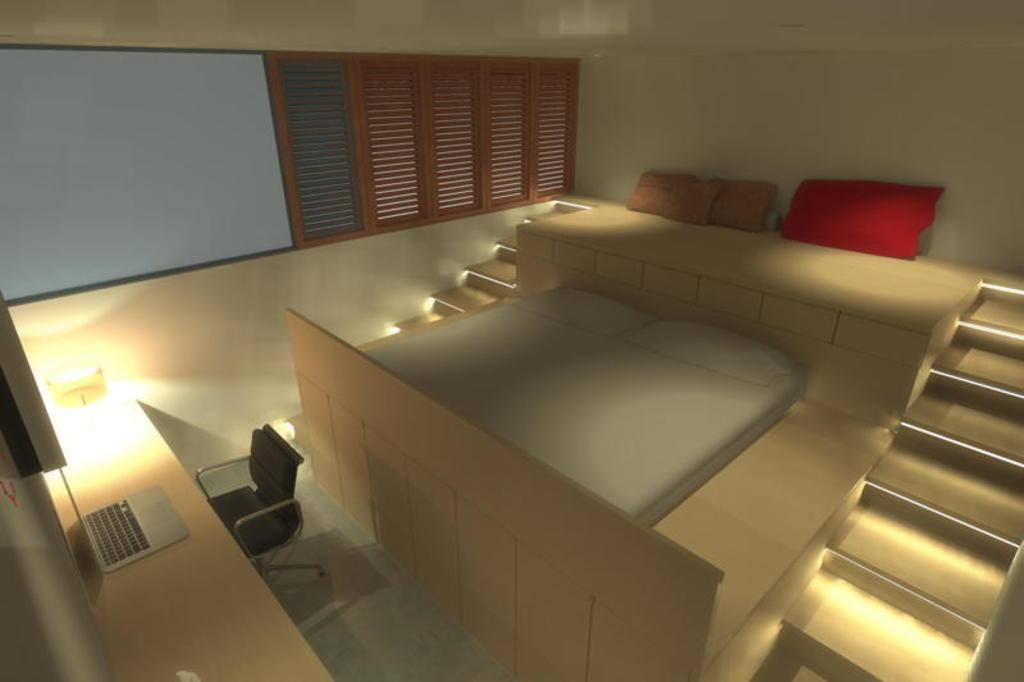What type of setting is depicted in the image? The image contains a beautiful interior. What piece of furniture is present in the image? There is a bed, a chair, and a laptop in the image. Are there any architectural features visible in the image? Yes, there are stairs in the image. What can be seen through the windows in the image? There are windows in the image, but the view is not specified. What type of lighting is present in the image? There is a lamp in the image. What type of amusement can be seen in the image? There is no amusement present in the image; it depicts a beautiful interior with furniture and architectural features. Can you see any ducks in the image? There are no ducks present in the image. 